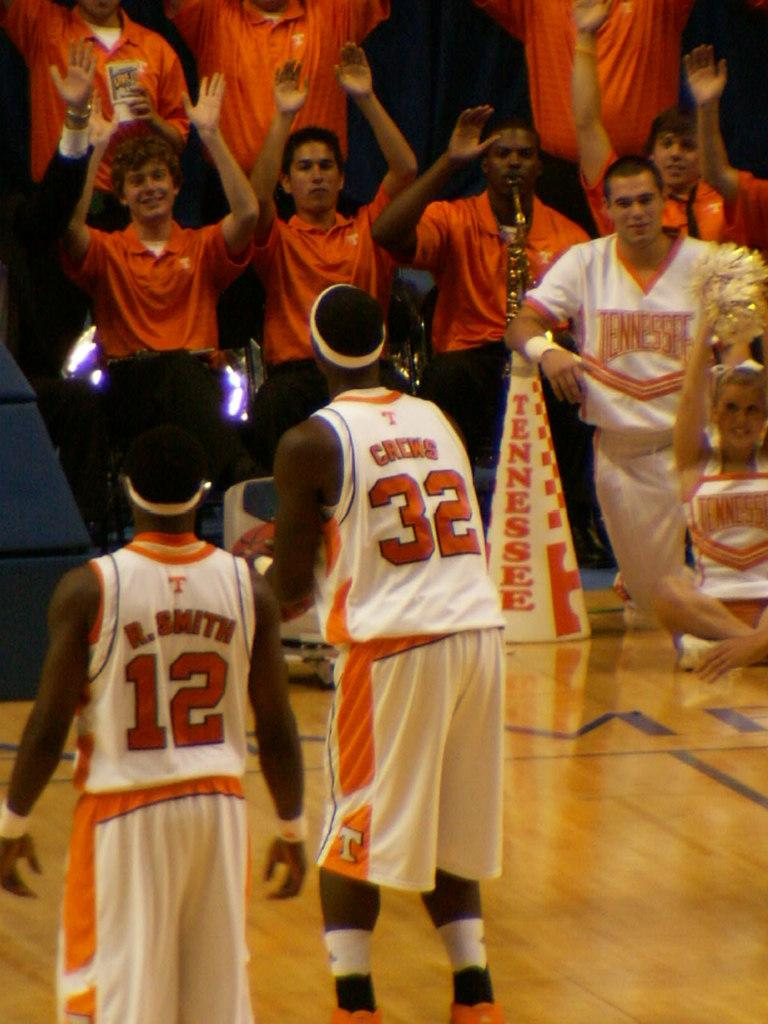Provide a one-sentence caption for the provided image. Basketball players wearing jersery number 12 and 32 face the crowd. 